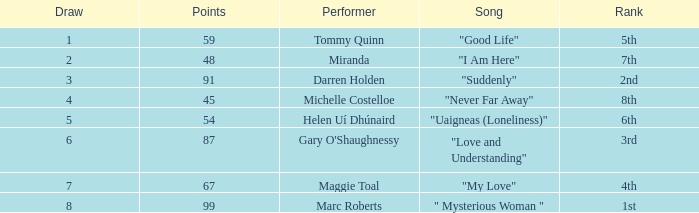What is the total number of draws for songs performed by Miranda with fewer than 48 points? 0.0. 